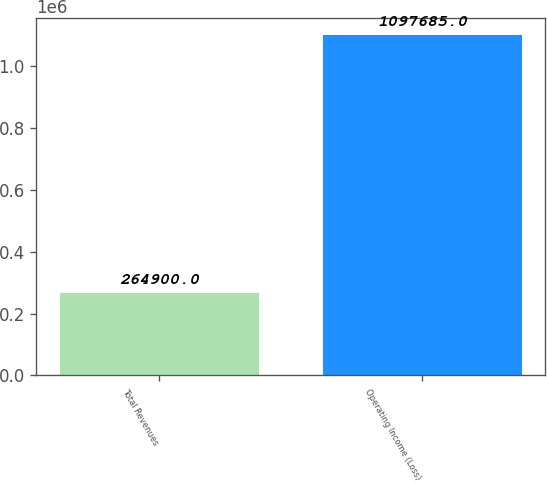<chart> <loc_0><loc_0><loc_500><loc_500><bar_chart><fcel>Total Revenues<fcel>Operating Income (Loss)<nl><fcel>264900<fcel>1.09768e+06<nl></chart> 